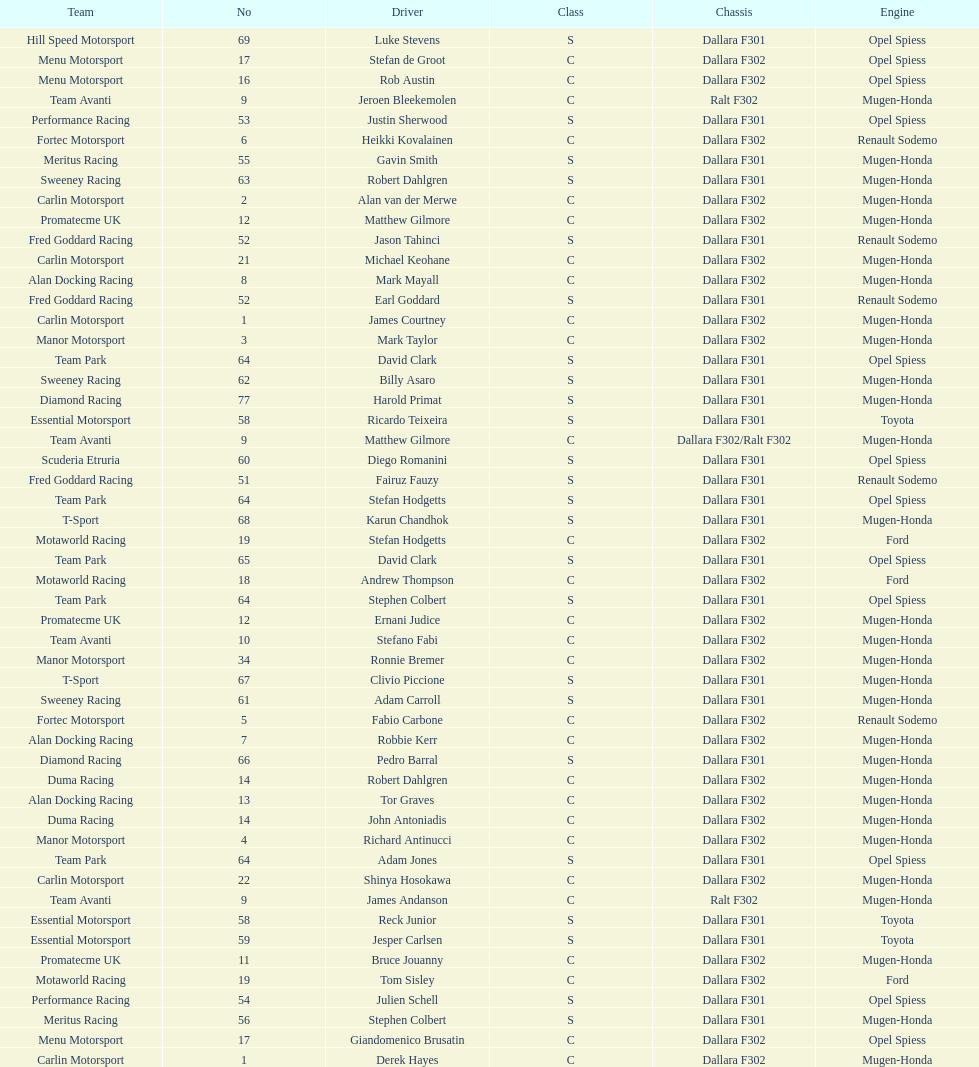Which engine was used the most by teams this season? Mugen-Honda. 